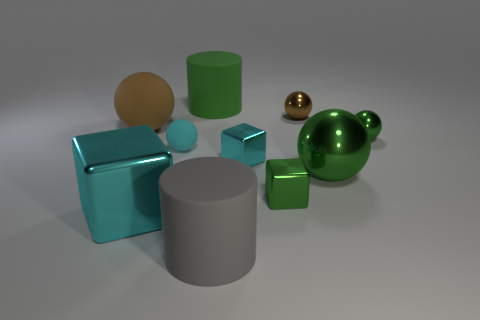Can you describe the different shapes present in the image and their arrangements? Certainly! The image presents a variety of geometric shapes arranged in a seemingly random configuration. We have a large green cylinder standing vertically, accompanied by smaller shapes such as cubes, spheres, and cylinders in colors like cyan, gold, and silver. The objects seem to be carefully placed to display a contrast in color, shape, and size, demonstrating an aesthetically pleasing composition and offering a study in geometry and spatial arrangement. 